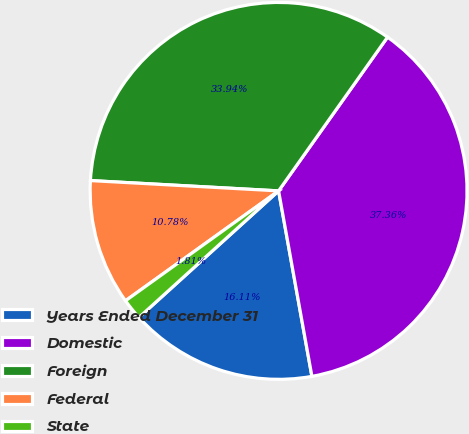<chart> <loc_0><loc_0><loc_500><loc_500><pie_chart><fcel>Years Ended December 31<fcel>Domestic<fcel>Foreign<fcel>Federal<fcel>State<nl><fcel>16.11%<fcel>37.36%<fcel>33.94%<fcel>10.78%<fcel>1.81%<nl></chart> 